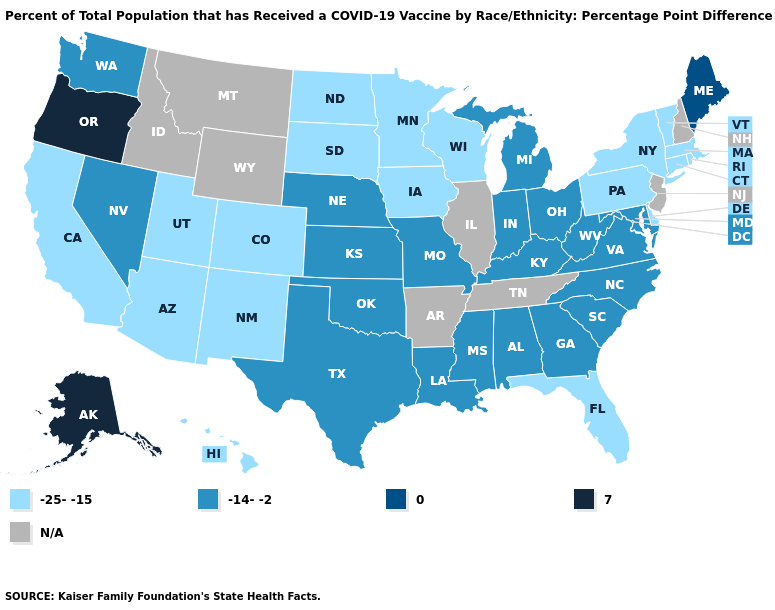Does Minnesota have the highest value in the MidWest?
Write a very short answer. No. What is the value of Indiana?
Give a very brief answer. -14--2. What is the highest value in states that border New Jersey?
Write a very short answer. -25--15. Does the map have missing data?
Short answer required. Yes. What is the lowest value in states that border Arizona?
Answer briefly. -25--15. What is the lowest value in states that border Virginia?
Concise answer only. -14--2. What is the value of Rhode Island?
Write a very short answer. -25--15. Does Texas have the lowest value in the South?
Keep it brief. No. What is the value of Montana?
Short answer required. N/A. Does Kansas have the highest value in the USA?
Be succinct. No. Name the states that have a value in the range 0?
Short answer required. Maine. Does the map have missing data?
Write a very short answer. Yes. 